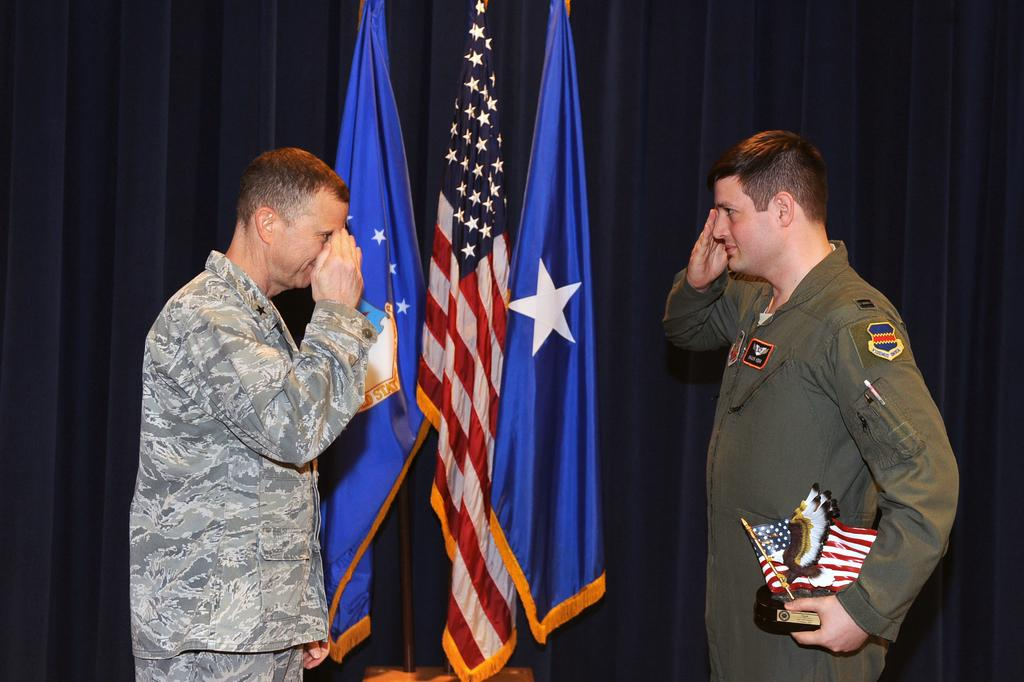How many people are in the image? There are two persons in the image. What is one of the persons doing in the image? One of the persons is holding an object. What can be seen in the image besides the people? There are flags and a curtain in the image. What type of scissors are being used to cut the oil in the image? There is no scissors or oil present in the image. What is the frame of the image made of? The frame of the image is not visible in the image, so it cannot be determined. 